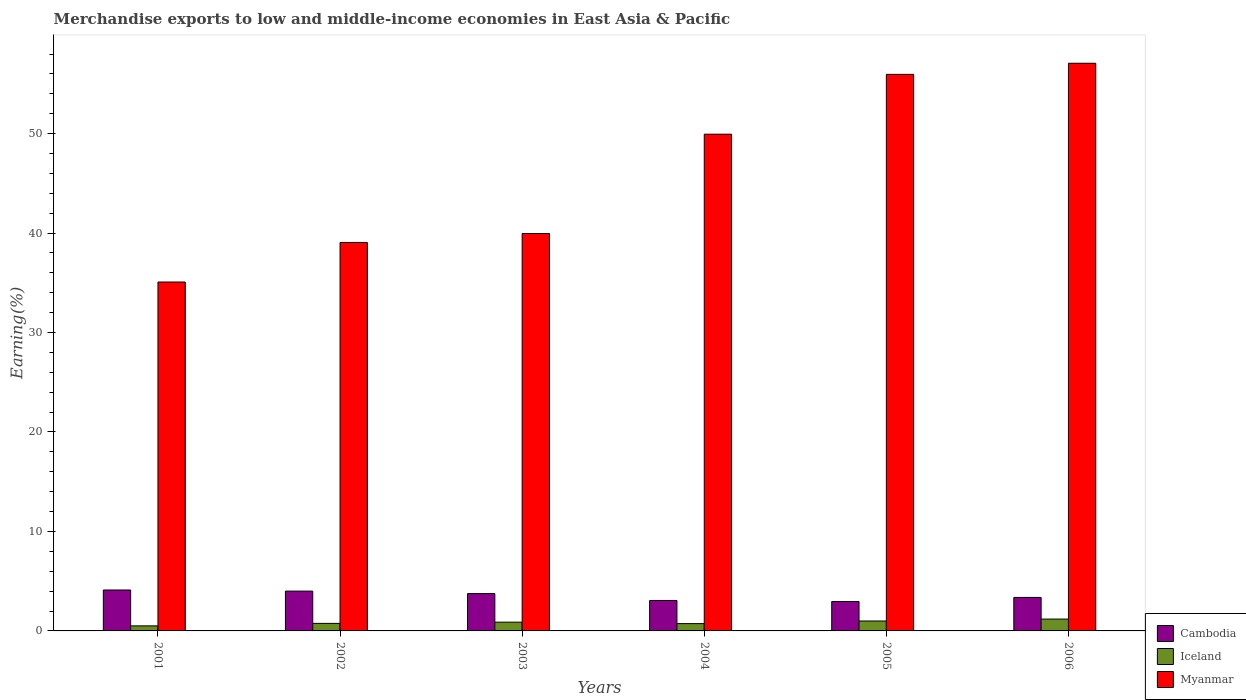Are the number of bars per tick equal to the number of legend labels?
Your answer should be compact. Yes. How many bars are there on the 5th tick from the left?
Keep it short and to the point. 3. How many bars are there on the 6th tick from the right?
Make the answer very short. 3. In how many cases, is the number of bars for a given year not equal to the number of legend labels?
Ensure brevity in your answer.  0. What is the percentage of amount earned from merchandise exports in Cambodia in 2002?
Provide a short and direct response. 4. Across all years, what is the maximum percentage of amount earned from merchandise exports in Myanmar?
Offer a very short reply. 57.07. Across all years, what is the minimum percentage of amount earned from merchandise exports in Iceland?
Offer a very short reply. 0.51. In which year was the percentage of amount earned from merchandise exports in Iceland minimum?
Your answer should be very brief. 2001. What is the total percentage of amount earned from merchandise exports in Myanmar in the graph?
Provide a short and direct response. 277.06. What is the difference between the percentage of amount earned from merchandise exports in Iceland in 2002 and that in 2006?
Offer a very short reply. -0.43. What is the difference between the percentage of amount earned from merchandise exports in Cambodia in 2001 and the percentage of amount earned from merchandise exports in Iceland in 2002?
Give a very brief answer. 3.36. What is the average percentage of amount earned from merchandise exports in Cambodia per year?
Make the answer very short. 3.54. In the year 2004, what is the difference between the percentage of amount earned from merchandise exports in Myanmar and percentage of amount earned from merchandise exports in Cambodia?
Provide a short and direct response. 46.88. What is the ratio of the percentage of amount earned from merchandise exports in Iceland in 2005 to that in 2006?
Your answer should be very brief. 0.84. What is the difference between the highest and the second highest percentage of amount earned from merchandise exports in Cambodia?
Your answer should be very brief. 0.11. What is the difference between the highest and the lowest percentage of amount earned from merchandise exports in Cambodia?
Give a very brief answer. 1.15. Is the sum of the percentage of amount earned from merchandise exports in Myanmar in 2003 and 2004 greater than the maximum percentage of amount earned from merchandise exports in Cambodia across all years?
Provide a succinct answer. Yes. What does the 1st bar from the right in 2006 represents?
Your response must be concise. Myanmar. How many bars are there?
Your response must be concise. 18. What is the difference between two consecutive major ticks on the Y-axis?
Offer a terse response. 10. Does the graph contain grids?
Offer a very short reply. No. How many legend labels are there?
Make the answer very short. 3. What is the title of the graph?
Provide a succinct answer. Merchandise exports to low and middle-income economies in East Asia & Pacific. Does "Grenada" appear as one of the legend labels in the graph?
Offer a very short reply. No. What is the label or title of the Y-axis?
Your answer should be very brief. Earning(%). What is the Earning(%) of Cambodia in 2001?
Provide a succinct answer. 4.11. What is the Earning(%) of Iceland in 2001?
Ensure brevity in your answer.  0.51. What is the Earning(%) of Myanmar in 2001?
Offer a terse response. 35.08. What is the Earning(%) of Cambodia in 2002?
Provide a short and direct response. 4. What is the Earning(%) of Iceland in 2002?
Your response must be concise. 0.76. What is the Earning(%) in Myanmar in 2002?
Provide a succinct answer. 39.06. What is the Earning(%) of Cambodia in 2003?
Give a very brief answer. 3.75. What is the Earning(%) in Iceland in 2003?
Offer a terse response. 0.88. What is the Earning(%) in Myanmar in 2003?
Your response must be concise. 39.96. What is the Earning(%) of Cambodia in 2004?
Your answer should be compact. 3.06. What is the Earning(%) in Iceland in 2004?
Provide a short and direct response. 0.73. What is the Earning(%) in Myanmar in 2004?
Offer a terse response. 49.94. What is the Earning(%) in Cambodia in 2005?
Provide a succinct answer. 2.96. What is the Earning(%) of Iceland in 2005?
Your answer should be compact. 1. What is the Earning(%) of Myanmar in 2005?
Your response must be concise. 55.96. What is the Earning(%) of Cambodia in 2006?
Offer a terse response. 3.37. What is the Earning(%) in Iceland in 2006?
Offer a terse response. 1.19. What is the Earning(%) of Myanmar in 2006?
Ensure brevity in your answer.  57.07. Across all years, what is the maximum Earning(%) in Cambodia?
Give a very brief answer. 4.11. Across all years, what is the maximum Earning(%) of Iceland?
Keep it short and to the point. 1.19. Across all years, what is the maximum Earning(%) of Myanmar?
Ensure brevity in your answer.  57.07. Across all years, what is the minimum Earning(%) in Cambodia?
Your answer should be compact. 2.96. Across all years, what is the minimum Earning(%) of Iceland?
Give a very brief answer. 0.51. Across all years, what is the minimum Earning(%) in Myanmar?
Your response must be concise. 35.08. What is the total Earning(%) in Cambodia in the graph?
Your answer should be very brief. 21.26. What is the total Earning(%) of Iceland in the graph?
Provide a succinct answer. 5.07. What is the total Earning(%) in Myanmar in the graph?
Offer a very short reply. 277.06. What is the difference between the Earning(%) in Cambodia in 2001 and that in 2002?
Your response must be concise. 0.11. What is the difference between the Earning(%) in Myanmar in 2001 and that in 2002?
Give a very brief answer. -3.98. What is the difference between the Earning(%) of Cambodia in 2001 and that in 2003?
Give a very brief answer. 0.36. What is the difference between the Earning(%) in Iceland in 2001 and that in 2003?
Ensure brevity in your answer.  -0.37. What is the difference between the Earning(%) of Myanmar in 2001 and that in 2003?
Offer a very short reply. -4.88. What is the difference between the Earning(%) in Cambodia in 2001 and that in 2004?
Offer a very short reply. 1.05. What is the difference between the Earning(%) of Iceland in 2001 and that in 2004?
Your answer should be very brief. -0.23. What is the difference between the Earning(%) in Myanmar in 2001 and that in 2004?
Keep it short and to the point. -14.86. What is the difference between the Earning(%) in Cambodia in 2001 and that in 2005?
Provide a short and direct response. 1.15. What is the difference between the Earning(%) in Iceland in 2001 and that in 2005?
Give a very brief answer. -0.49. What is the difference between the Earning(%) in Myanmar in 2001 and that in 2005?
Provide a short and direct response. -20.88. What is the difference between the Earning(%) of Cambodia in 2001 and that in 2006?
Offer a very short reply. 0.75. What is the difference between the Earning(%) of Iceland in 2001 and that in 2006?
Your answer should be very brief. -0.68. What is the difference between the Earning(%) of Myanmar in 2001 and that in 2006?
Give a very brief answer. -22. What is the difference between the Earning(%) of Cambodia in 2002 and that in 2003?
Provide a succinct answer. 0.25. What is the difference between the Earning(%) in Iceland in 2002 and that in 2003?
Your answer should be very brief. -0.12. What is the difference between the Earning(%) of Myanmar in 2002 and that in 2003?
Provide a short and direct response. -0.9. What is the difference between the Earning(%) of Cambodia in 2002 and that in 2004?
Keep it short and to the point. 0.94. What is the difference between the Earning(%) in Iceland in 2002 and that in 2004?
Ensure brevity in your answer.  0.02. What is the difference between the Earning(%) in Myanmar in 2002 and that in 2004?
Offer a terse response. -10.88. What is the difference between the Earning(%) of Cambodia in 2002 and that in 2005?
Keep it short and to the point. 1.04. What is the difference between the Earning(%) in Iceland in 2002 and that in 2005?
Your answer should be compact. -0.24. What is the difference between the Earning(%) of Myanmar in 2002 and that in 2005?
Provide a short and direct response. -16.9. What is the difference between the Earning(%) in Cambodia in 2002 and that in 2006?
Give a very brief answer. 0.64. What is the difference between the Earning(%) in Iceland in 2002 and that in 2006?
Your answer should be compact. -0.43. What is the difference between the Earning(%) in Myanmar in 2002 and that in 2006?
Provide a succinct answer. -18.02. What is the difference between the Earning(%) of Cambodia in 2003 and that in 2004?
Your answer should be very brief. 0.69. What is the difference between the Earning(%) of Iceland in 2003 and that in 2004?
Your answer should be compact. 0.15. What is the difference between the Earning(%) of Myanmar in 2003 and that in 2004?
Your answer should be compact. -9.98. What is the difference between the Earning(%) of Cambodia in 2003 and that in 2005?
Ensure brevity in your answer.  0.79. What is the difference between the Earning(%) in Iceland in 2003 and that in 2005?
Your answer should be compact. -0.12. What is the difference between the Earning(%) of Myanmar in 2003 and that in 2005?
Your answer should be very brief. -16. What is the difference between the Earning(%) of Cambodia in 2003 and that in 2006?
Provide a short and direct response. 0.38. What is the difference between the Earning(%) in Iceland in 2003 and that in 2006?
Your answer should be very brief. -0.31. What is the difference between the Earning(%) of Myanmar in 2003 and that in 2006?
Ensure brevity in your answer.  -17.12. What is the difference between the Earning(%) of Cambodia in 2004 and that in 2005?
Offer a very short reply. 0.1. What is the difference between the Earning(%) in Iceland in 2004 and that in 2005?
Your answer should be very brief. -0.26. What is the difference between the Earning(%) in Myanmar in 2004 and that in 2005?
Offer a terse response. -6.02. What is the difference between the Earning(%) in Cambodia in 2004 and that in 2006?
Your response must be concise. -0.3. What is the difference between the Earning(%) in Iceland in 2004 and that in 2006?
Provide a short and direct response. -0.46. What is the difference between the Earning(%) of Myanmar in 2004 and that in 2006?
Keep it short and to the point. -7.13. What is the difference between the Earning(%) of Cambodia in 2005 and that in 2006?
Keep it short and to the point. -0.41. What is the difference between the Earning(%) in Iceland in 2005 and that in 2006?
Give a very brief answer. -0.19. What is the difference between the Earning(%) in Myanmar in 2005 and that in 2006?
Keep it short and to the point. -1.12. What is the difference between the Earning(%) of Cambodia in 2001 and the Earning(%) of Iceland in 2002?
Your answer should be very brief. 3.36. What is the difference between the Earning(%) in Cambodia in 2001 and the Earning(%) in Myanmar in 2002?
Your response must be concise. -34.94. What is the difference between the Earning(%) in Iceland in 2001 and the Earning(%) in Myanmar in 2002?
Offer a terse response. -38.55. What is the difference between the Earning(%) of Cambodia in 2001 and the Earning(%) of Iceland in 2003?
Your response must be concise. 3.23. What is the difference between the Earning(%) of Cambodia in 2001 and the Earning(%) of Myanmar in 2003?
Keep it short and to the point. -35.84. What is the difference between the Earning(%) in Iceland in 2001 and the Earning(%) in Myanmar in 2003?
Give a very brief answer. -39.45. What is the difference between the Earning(%) of Cambodia in 2001 and the Earning(%) of Iceland in 2004?
Give a very brief answer. 3.38. What is the difference between the Earning(%) of Cambodia in 2001 and the Earning(%) of Myanmar in 2004?
Make the answer very short. -45.83. What is the difference between the Earning(%) in Iceland in 2001 and the Earning(%) in Myanmar in 2004?
Keep it short and to the point. -49.43. What is the difference between the Earning(%) in Cambodia in 2001 and the Earning(%) in Iceland in 2005?
Your response must be concise. 3.12. What is the difference between the Earning(%) in Cambodia in 2001 and the Earning(%) in Myanmar in 2005?
Keep it short and to the point. -51.84. What is the difference between the Earning(%) in Iceland in 2001 and the Earning(%) in Myanmar in 2005?
Ensure brevity in your answer.  -55.45. What is the difference between the Earning(%) of Cambodia in 2001 and the Earning(%) of Iceland in 2006?
Offer a terse response. 2.92. What is the difference between the Earning(%) in Cambodia in 2001 and the Earning(%) in Myanmar in 2006?
Offer a very short reply. -52.96. What is the difference between the Earning(%) of Iceland in 2001 and the Earning(%) of Myanmar in 2006?
Give a very brief answer. -56.57. What is the difference between the Earning(%) in Cambodia in 2002 and the Earning(%) in Iceland in 2003?
Your response must be concise. 3.12. What is the difference between the Earning(%) in Cambodia in 2002 and the Earning(%) in Myanmar in 2003?
Provide a succinct answer. -35.95. What is the difference between the Earning(%) in Iceland in 2002 and the Earning(%) in Myanmar in 2003?
Ensure brevity in your answer.  -39.2. What is the difference between the Earning(%) of Cambodia in 2002 and the Earning(%) of Iceland in 2004?
Ensure brevity in your answer.  3.27. What is the difference between the Earning(%) of Cambodia in 2002 and the Earning(%) of Myanmar in 2004?
Make the answer very short. -45.94. What is the difference between the Earning(%) of Iceland in 2002 and the Earning(%) of Myanmar in 2004?
Offer a very short reply. -49.18. What is the difference between the Earning(%) in Cambodia in 2002 and the Earning(%) in Iceland in 2005?
Offer a terse response. 3.01. What is the difference between the Earning(%) in Cambodia in 2002 and the Earning(%) in Myanmar in 2005?
Provide a short and direct response. -51.95. What is the difference between the Earning(%) in Iceland in 2002 and the Earning(%) in Myanmar in 2005?
Offer a very short reply. -55.2. What is the difference between the Earning(%) of Cambodia in 2002 and the Earning(%) of Iceland in 2006?
Offer a very short reply. 2.81. What is the difference between the Earning(%) in Cambodia in 2002 and the Earning(%) in Myanmar in 2006?
Make the answer very short. -53.07. What is the difference between the Earning(%) of Iceland in 2002 and the Earning(%) of Myanmar in 2006?
Ensure brevity in your answer.  -56.32. What is the difference between the Earning(%) of Cambodia in 2003 and the Earning(%) of Iceland in 2004?
Offer a terse response. 3.02. What is the difference between the Earning(%) of Cambodia in 2003 and the Earning(%) of Myanmar in 2004?
Your answer should be compact. -46.19. What is the difference between the Earning(%) in Iceland in 2003 and the Earning(%) in Myanmar in 2004?
Your answer should be very brief. -49.06. What is the difference between the Earning(%) in Cambodia in 2003 and the Earning(%) in Iceland in 2005?
Give a very brief answer. 2.75. What is the difference between the Earning(%) of Cambodia in 2003 and the Earning(%) of Myanmar in 2005?
Make the answer very short. -52.21. What is the difference between the Earning(%) of Iceland in 2003 and the Earning(%) of Myanmar in 2005?
Offer a terse response. -55.08. What is the difference between the Earning(%) of Cambodia in 2003 and the Earning(%) of Iceland in 2006?
Give a very brief answer. 2.56. What is the difference between the Earning(%) of Cambodia in 2003 and the Earning(%) of Myanmar in 2006?
Keep it short and to the point. -53.32. What is the difference between the Earning(%) in Iceland in 2003 and the Earning(%) in Myanmar in 2006?
Offer a very short reply. -56.19. What is the difference between the Earning(%) of Cambodia in 2004 and the Earning(%) of Iceland in 2005?
Provide a succinct answer. 2.07. What is the difference between the Earning(%) of Cambodia in 2004 and the Earning(%) of Myanmar in 2005?
Offer a terse response. -52.89. What is the difference between the Earning(%) of Iceland in 2004 and the Earning(%) of Myanmar in 2005?
Your answer should be very brief. -55.22. What is the difference between the Earning(%) in Cambodia in 2004 and the Earning(%) in Iceland in 2006?
Provide a succinct answer. 1.87. What is the difference between the Earning(%) in Cambodia in 2004 and the Earning(%) in Myanmar in 2006?
Provide a succinct answer. -54.01. What is the difference between the Earning(%) of Iceland in 2004 and the Earning(%) of Myanmar in 2006?
Provide a short and direct response. -56.34. What is the difference between the Earning(%) of Cambodia in 2005 and the Earning(%) of Iceland in 2006?
Your response must be concise. 1.77. What is the difference between the Earning(%) of Cambodia in 2005 and the Earning(%) of Myanmar in 2006?
Provide a succinct answer. -54.11. What is the difference between the Earning(%) in Iceland in 2005 and the Earning(%) in Myanmar in 2006?
Give a very brief answer. -56.08. What is the average Earning(%) in Cambodia per year?
Your answer should be compact. 3.54. What is the average Earning(%) of Iceland per year?
Provide a succinct answer. 0.84. What is the average Earning(%) of Myanmar per year?
Your answer should be very brief. 46.18. In the year 2001, what is the difference between the Earning(%) in Cambodia and Earning(%) in Iceland?
Your answer should be compact. 3.61. In the year 2001, what is the difference between the Earning(%) in Cambodia and Earning(%) in Myanmar?
Offer a terse response. -30.96. In the year 2001, what is the difference between the Earning(%) of Iceland and Earning(%) of Myanmar?
Make the answer very short. -34.57. In the year 2002, what is the difference between the Earning(%) in Cambodia and Earning(%) in Iceland?
Your answer should be very brief. 3.25. In the year 2002, what is the difference between the Earning(%) of Cambodia and Earning(%) of Myanmar?
Your answer should be very brief. -35.05. In the year 2002, what is the difference between the Earning(%) in Iceland and Earning(%) in Myanmar?
Ensure brevity in your answer.  -38.3. In the year 2003, what is the difference between the Earning(%) in Cambodia and Earning(%) in Iceland?
Give a very brief answer. 2.87. In the year 2003, what is the difference between the Earning(%) in Cambodia and Earning(%) in Myanmar?
Make the answer very short. -36.21. In the year 2003, what is the difference between the Earning(%) in Iceland and Earning(%) in Myanmar?
Make the answer very short. -39.08. In the year 2004, what is the difference between the Earning(%) of Cambodia and Earning(%) of Iceland?
Your answer should be compact. 2.33. In the year 2004, what is the difference between the Earning(%) of Cambodia and Earning(%) of Myanmar?
Give a very brief answer. -46.88. In the year 2004, what is the difference between the Earning(%) in Iceland and Earning(%) in Myanmar?
Provide a short and direct response. -49.21. In the year 2005, what is the difference between the Earning(%) of Cambodia and Earning(%) of Iceland?
Your response must be concise. 1.96. In the year 2005, what is the difference between the Earning(%) in Cambodia and Earning(%) in Myanmar?
Give a very brief answer. -53. In the year 2005, what is the difference between the Earning(%) of Iceland and Earning(%) of Myanmar?
Your answer should be very brief. -54.96. In the year 2006, what is the difference between the Earning(%) of Cambodia and Earning(%) of Iceland?
Your answer should be very brief. 2.18. In the year 2006, what is the difference between the Earning(%) in Cambodia and Earning(%) in Myanmar?
Provide a short and direct response. -53.71. In the year 2006, what is the difference between the Earning(%) of Iceland and Earning(%) of Myanmar?
Give a very brief answer. -55.88. What is the ratio of the Earning(%) of Cambodia in 2001 to that in 2002?
Offer a very short reply. 1.03. What is the ratio of the Earning(%) of Iceland in 2001 to that in 2002?
Your answer should be compact. 0.67. What is the ratio of the Earning(%) in Myanmar in 2001 to that in 2002?
Offer a very short reply. 0.9. What is the ratio of the Earning(%) in Cambodia in 2001 to that in 2003?
Give a very brief answer. 1.1. What is the ratio of the Earning(%) in Iceland in 2001 to that in 2003?
Your answer should be very brief. 0.58. What is the ratio of the Earning(%) in Myanmar in 2001 to that in 2003?
Offer a terse response. 0.88. What is the ratio of the Earning(%) in Cambodia in 2001 to that in 2004?
Offer a very short reply. 1.34. What is the ratio of the Earning(%) in Iceland in 2001 to that in 2004?
Offer a terse response. 0.69. What is the ratio of the Earning(%) of Myanmar in 2001 to that in 2004?
Your answer should be very brief. 0.7. What is the ratio of the Earning(%) of Cambodia in 2001 to that in 2005?
Your answer should be very brief. 1.39. What is the ratio of the Earning(%) of Iceland in 2001 to that in 2005?
Provide a succinct answer. 0.51. What is the ratio of the Earning(%) of Myanmar in 2001 to that in 2005?
Keep it short and to the point. 0.63. What is the ratio of the Earning(%) of Cambodia in 2001 to that in 2006?
Your response must be concise. 1.22. What is the ratio of the Earning(%) in Iceland in 2001 to that in 2006?
Make the answer very short. 0.43. What is the ratio of the Earning(%) in Myanmar in 2001 to that in 2006?
Your response must be concise. 0.61. What is the ratio of the Earning(%) in Cambodia in 2002 to that in 2003?
Provide a succinct answer. 1.07. What is the ratio of the Earning(%) of Iceland in 2002 to that in 2003?
Your answer should be compact. 0.86. What is the ratio of the Earning(%) of Myanmar in 2002 to that in 2003?
Your answer should be very brief. 0.98. What is the ratio of the Earning(%) of Cambodia in 2002 to that in 2004?
Provide a succinct answer. 1.31. What is the ratio of the Earning(%) of Myanmar in 2002 to that in 2004?
Provide a succinct answer. 0.78. What is the ratio of the Earning(%) in Cambodia in 2002 to that in 2005?
Your response must be concise. 1.35. What is the ratio of the Earning(%) of Iceland in 2002 to that in 2005?
Keep it short and to the point. 0.76. What is the ratio of the Earning(%) in Myanmar in 2002 to that in 2005?
Offer a very short reply. 0.7. What is the ratio of the Earning(%) of Cambodia in 2002 to that in 2006?
Make the answer very short. 1.19. What is the ratio of the Earning(%) in Iceland in 2002 to that in 2006?
Your response must be concise. 0.64. What is the ratio of the Earning(%) of Myanmar in 2002 to that in 2006?
Give a very brief answer. 0.68. What is the ratio of the Earning(%) of Cambodia in 2003 to that in 2004?
Keep it short and to the point. 1.22. What is the ratio of the Earning(%) in Iceland in 2003 to that in 2004?
Keep it short and to the point. 1.2. What is the ratio of the Earning(%) of Myanmar in 2003 to that in 2004?
Provide a short and direct response. 0.8. What is the ratio of the Earning(%) of Cambodia in 2003 to that in 2005?
Give a very brief answer. 1.27. What is the ratio of the Earning(%) in Iceland in 2003 to that in 2005?
Your answer should be very brief. 0.88. What is the ratio of the Earning(%) in Myanmar in 2003 to that in 2005?
Provide a succinct answer. 0.71. What is the ratio of the Earning(%) in Cambodia in 2003 to that in 2006?
Provide a succinct answer. 1.11. What is the ratio of the Earning(%) of Iceland in 2003 to that in 2006?
Keep it short and to the point. 0.74. What is the ratio of the Earning(%) in Myanmar in 2003 to that in 2006?
Ensure brevity in your answer.  0.7. What is the ratio of the Earning(%) of Cambodia in 2004 to that in 2005?
Provide a succinct answer. 1.03. What is the ratio of the Earning(%) in Iceland in 2004 to that in 2005?
Ensure brevity in your answer.  0.74. What is the ratio of the Earning(%) of Myanmar in 2004 to that in 2005?
Ensure brevity in your answer.  0.89. What is the ratio of the Earning(%) of Cambodia in 2004 to that in 2006?
Your answer should be very brief. 0.91. What is the ratio of the Earning(%) in Iceland in 2004 to that in 2006?
Keep it short and to the point. 0.62. What is the ratio of the Earning(%) in Myanmar in 2004 to that in 2006?
Offer a very short reply. 0.88. What is the ratio of the Earning(%) in Cambodia in 2005 to that in 2006?
Ensure brevity in your answer.  0.88. What is the ratio of the Earning(%) of Iceland in 2005 to that in 2006?
Give a very brief answer. 0.84. What is the ratio of the Earning(%) of Myanmar in 2005 to that in 2006?
Ensure brevity in your answer.  0.98. What is the difference between the highest and the second highest Earning(%) of Cambodia?
Provide a short and direct response. 0.11. What is the difference between the highest and the second highest Earning(%) in Iceland?
Provide a succinct answer. 0.19. What is the difference between the highest and the second highest Earning(%) in Myanmar?
Provide a succinct answer. 1.12. What is the difference between the highest and the lowest Earning(%) of Cambodia?
Provide a short and direct response. 1.15. What is the difference between the highest and the lowest Earning(%) in Iceland?
Offer a very short reply. 0.68. What is the difference between the highest and the lowest Earning(%) in Myanmar?
Give a very brief answer. 22. 